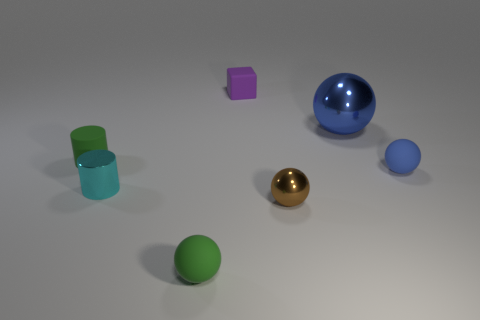What time of day or lighting condition does the image imply? The image suggests an indoor setting with controlled lighting. There is a gentle dispersion of light across the scene indicating a possible artificial light source above the objects, like that from a lamp or ceiling light. There are no strong shadows or indications of natural light such as sunlight, reaffirming the likelihood of an interior space with an overhead artificial light source. 